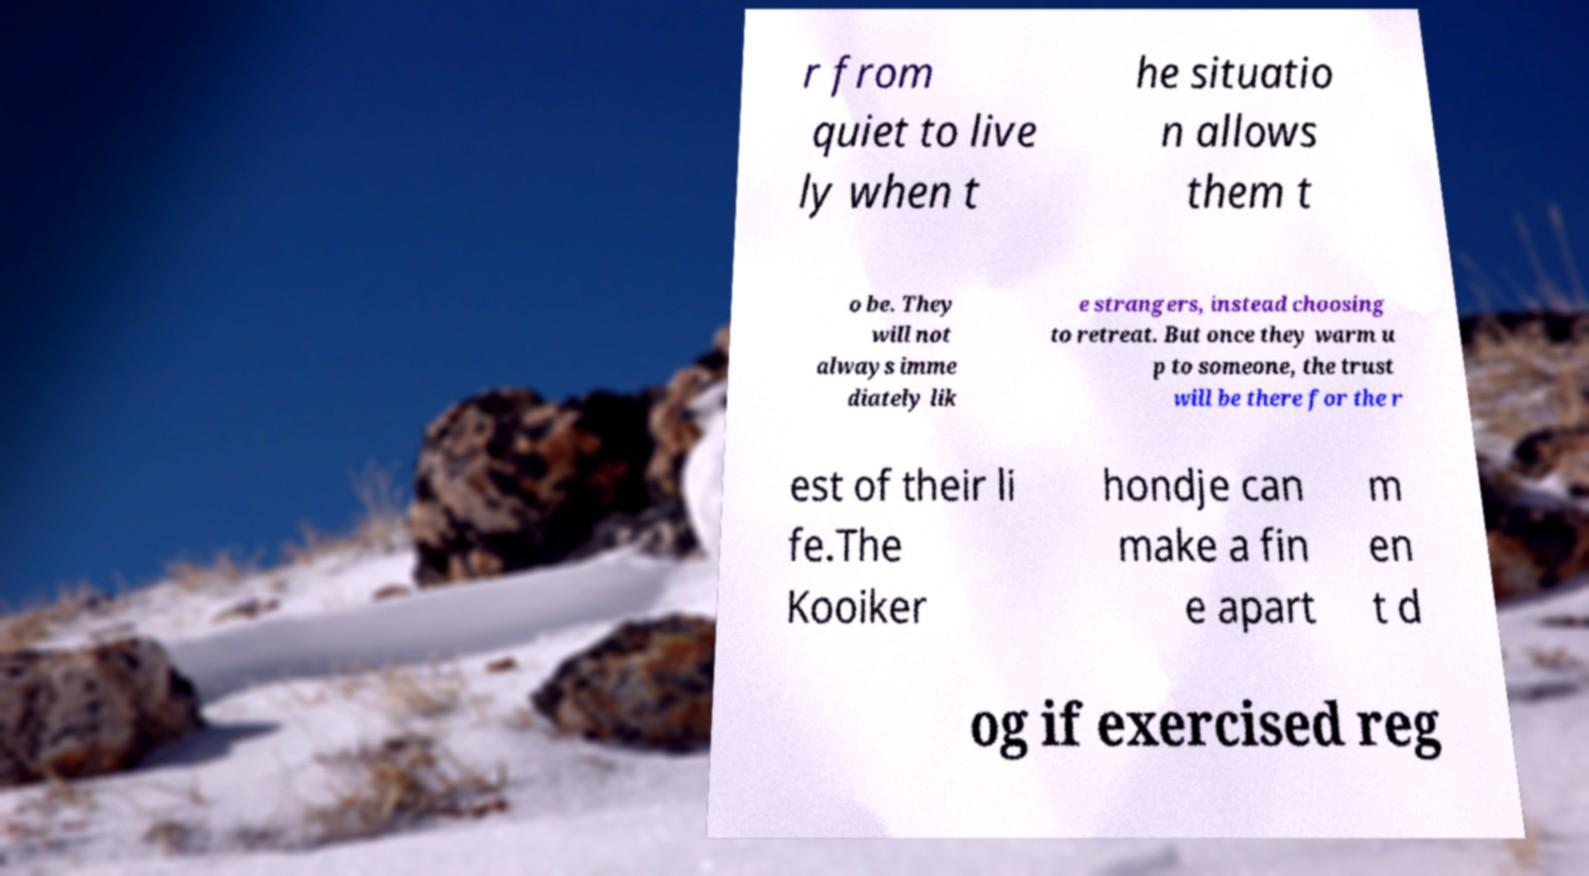Please identify and transcribe the text found in this image. r from quiet to live ly when t he situatio n allows them t o be. They will not always imme diately lik e strangers, instead choosing to retreat. But once they warm u p to someone, the trust will be there for the r est of their li fe.The Kooiker hondje can make a fin e apart m en t d og if exercised reg 